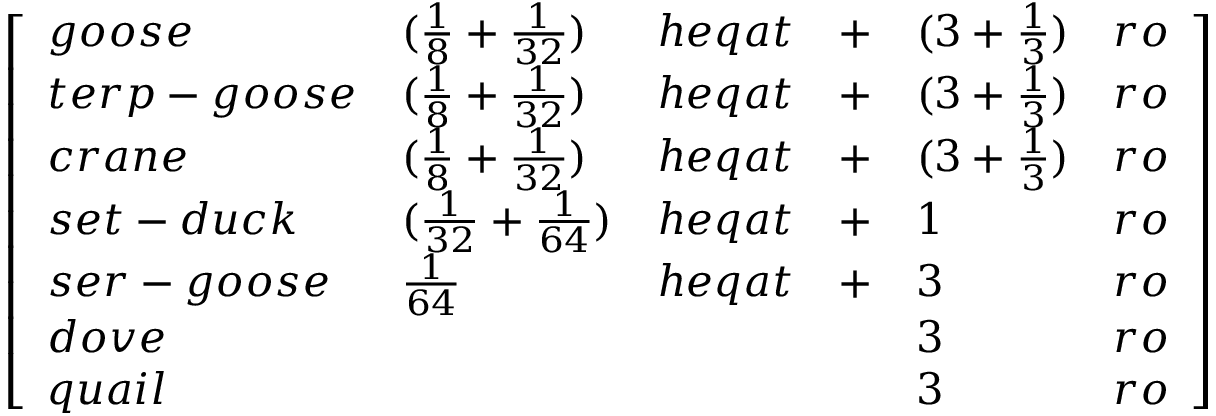<formula> <loc_0><loc_0><loc_500><loc_500>{ \left [ \begin{array} { l l l l l l } { g o o s e } & { ( { \frac { 1 } { 8 } } + { \frac { 1 } { 3 2 } } ) } & { h e q a t } & { + } & { ( 3 + { \frac { 1 } { 3 } } ) } & { r o } \\ { t e r p - g o o s e } & { ( { \frac { 1 } { 8 } } + { \frac { 1 } { 3 2 } } ) } & { h e q a t } & { + } & { ( 3 + { \frac { 1 } { 3 } } ) } & { r o } \\ { c r a n e } & { ( { \frac { 1 } { 8 } } + { \frac { 1 } { 3 2 } } ) } & { h e q a t } & { + } & { ( 3 + { \frac { 1 } { 3 } } ) } & { r o } \\ { s e t - d u c k } & { ( { \frac { 1 } { 3 2 } } + { \frac { 1 } { 6 4 } } ) } & { h e q a t } & { + } & { 1 } & { r o } \\ { s e r - g o o s e } & { { \frac { 1 } { 6 4 } } } & { h e q a t } & { + } & { 3 } & { r o } \\ { d o v e } & & & & { 3 } & { r o } \\ { q u a i l } & & & & { 3 } & { r o } \end{array} \right ] }</formula> 